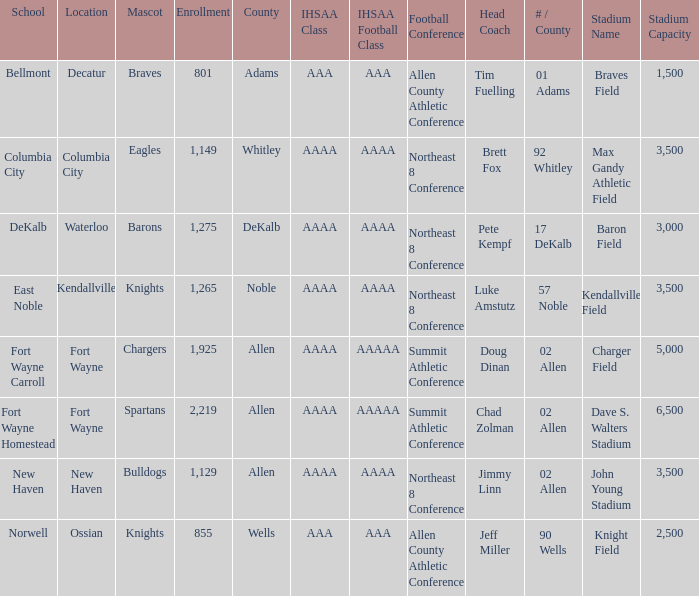What's the enrollment for Kendallville? 1265.0. 